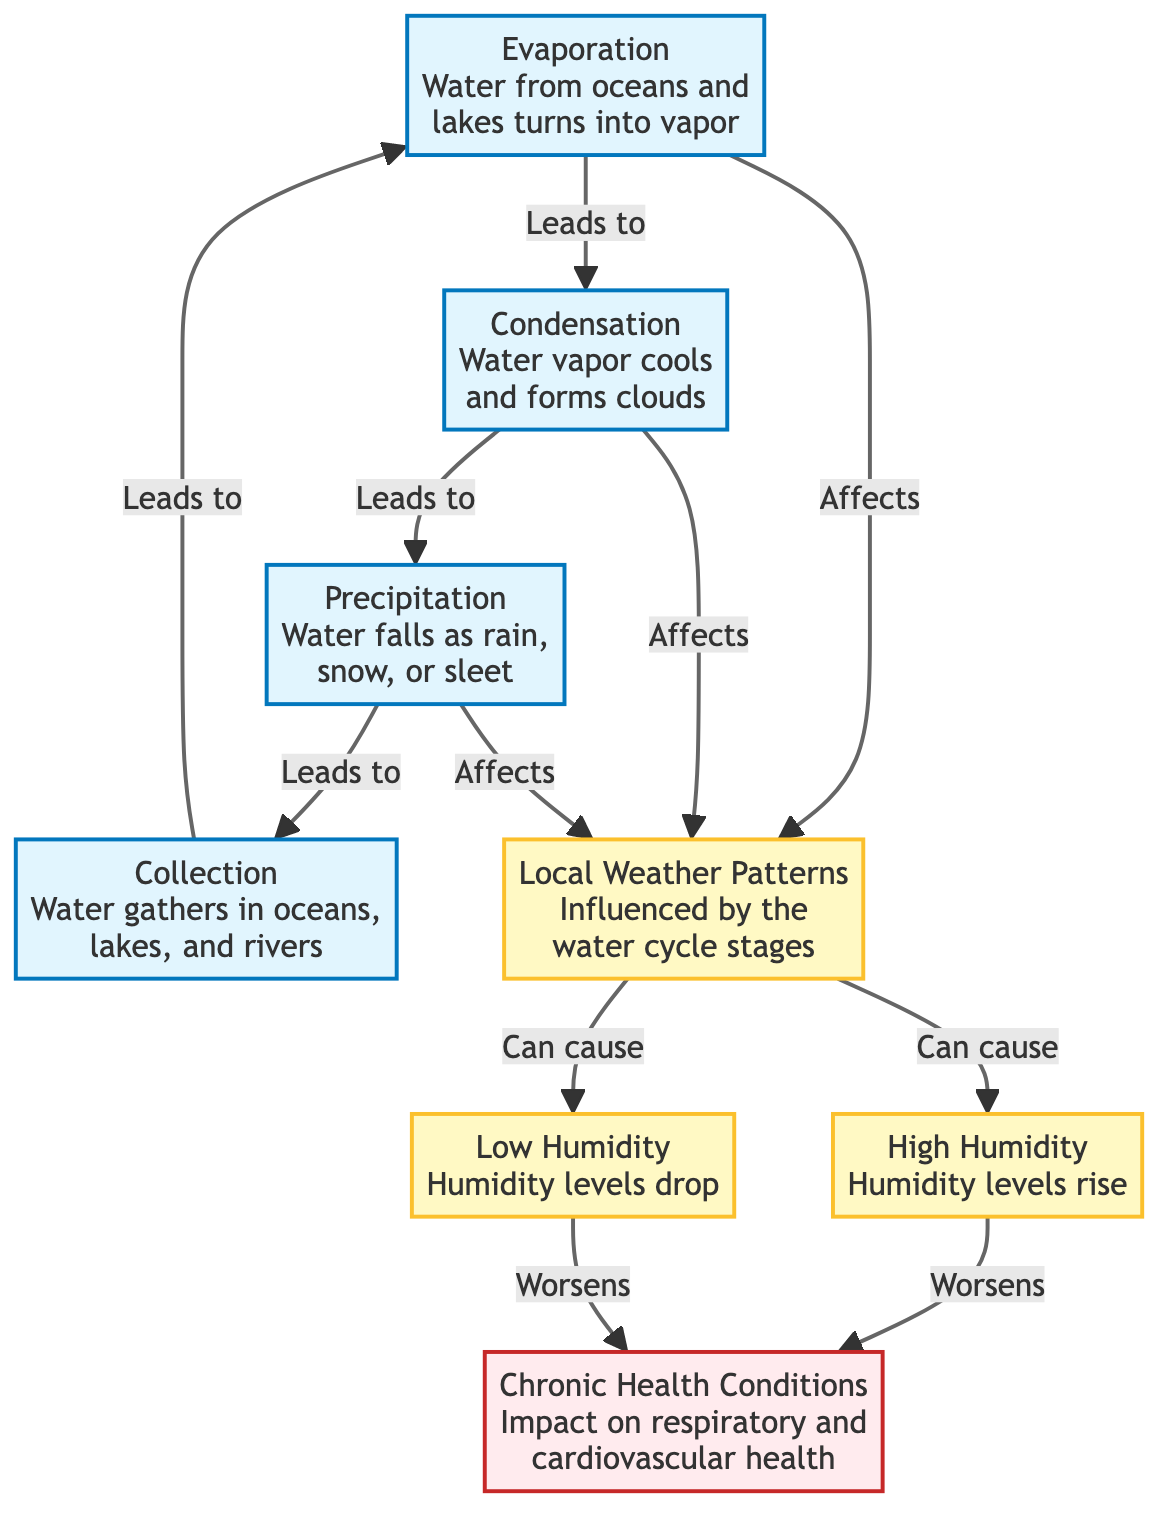What is the first stage of the water cycle in the diagram? The diagram shows "Evaporation" as the initial stage of the water cycle, as it is the first node from which others are derived.
Answer: Evaporation How many stages are there in the water cycle? By counting the nodes representing the stages, we find there are four stages: Evaporation, Condensation, Precipitation, and Collection.
Answer: Four Which weather condition results from local weather patterns? The diagram indicates that local weather patterns can lead to "High Humidity" and "Low Humidity," thus both conditions can result from them.
Answer: High Humidity, Low Humidity What effect does high humidity have on health conditions? According to the diagram, high humidity "Worsens" chronic health conditions, indicating a negative impact on health.
Answer: Worsens Which stage directly precedes precipitation in the water cycle? Following the flow from Evaporation to Condensation, we see that "Condensation" is the stage that directly precedes "Precipitation."
Answer: Condensation What do "High Humidity" and "Low Humidity" have in common? Both "High Humidity" and "Low Humidity" are outcomes of "Local Weather Patterns," making them related and a result of environmental influences.
Answer: Local Weather Patterns What is the relationship between precipitation and collection? The diagram shows that "Precipitation" directly leads to "Collection," indicating a cause-and-effect relationship between the two stages.
Answer: Leads to How does condensation affect local weather patterns? The diagram states that "Condensation" affects "Local Weather Patterns," implying that changes in condensation influence weather conditions in the area.
Answer: Affects What can be inferred if evaporation levels increase? An increase in evaporation would lead to more condensation and consequently more precipitation, which would ultimately affect local weather patterns significantly.
Answer: More condensation and precipitation 